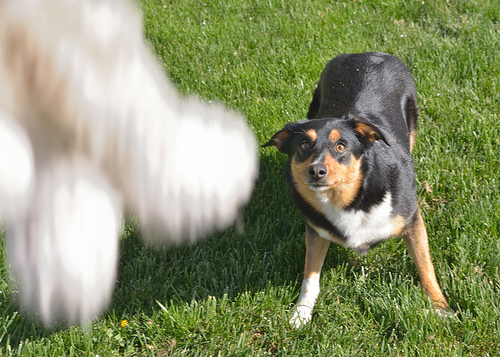<image>
Can you confirm if the dog is on the grass? Yes. Looking at the image, I can see the dog is positioned on top of the grass, with the grass providing support. Is there a toy above the dog? Yes. The toy is positioned above the dog in the vertical space, higher up in the scene. 